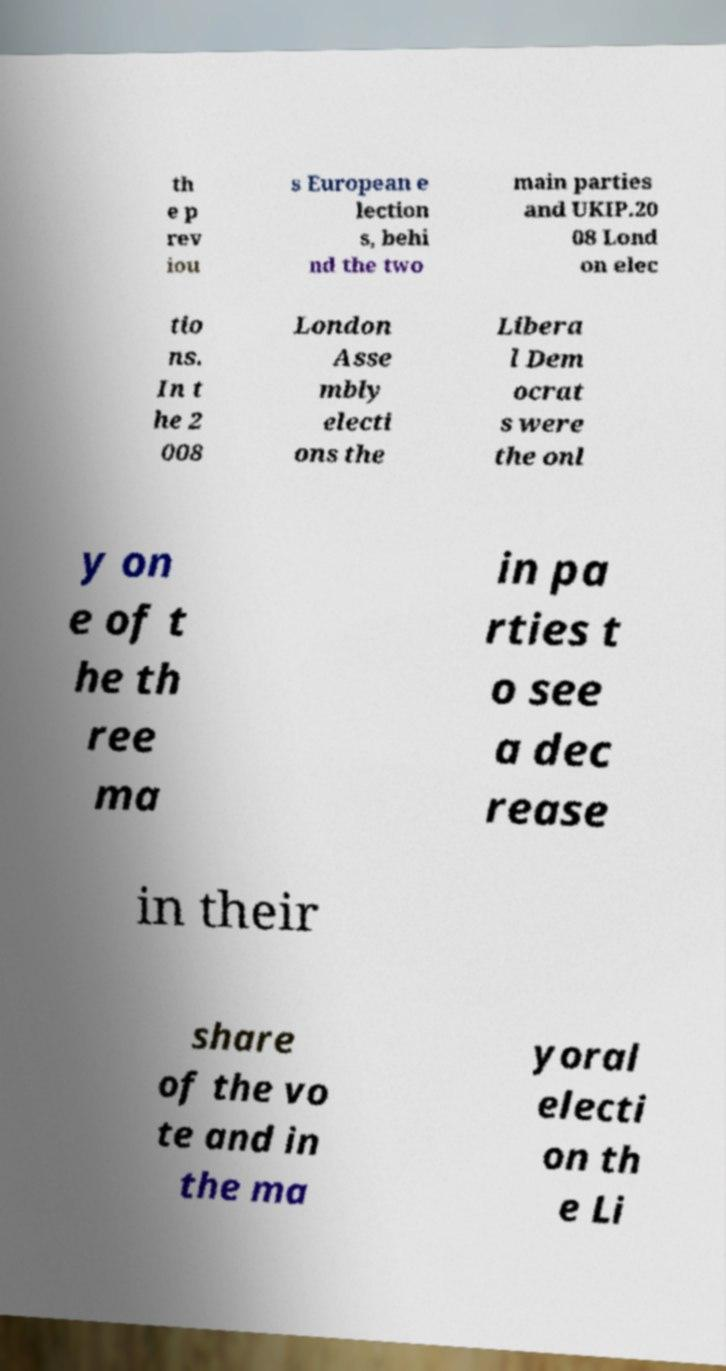Please read and relay the text visible in this image. What does it say? th e p rev iou s European e lection s, behi nd the two main parties and UKIP.20 08 Lond on elec tio ns. In t he 2 008 London Asse mbly electi ons the Libera l Dem ocrat s were the onl y on e of t he th ree ma in pa rties t o see a dec rease in their share of the vo te and in the ma yoral electi on th e Li 